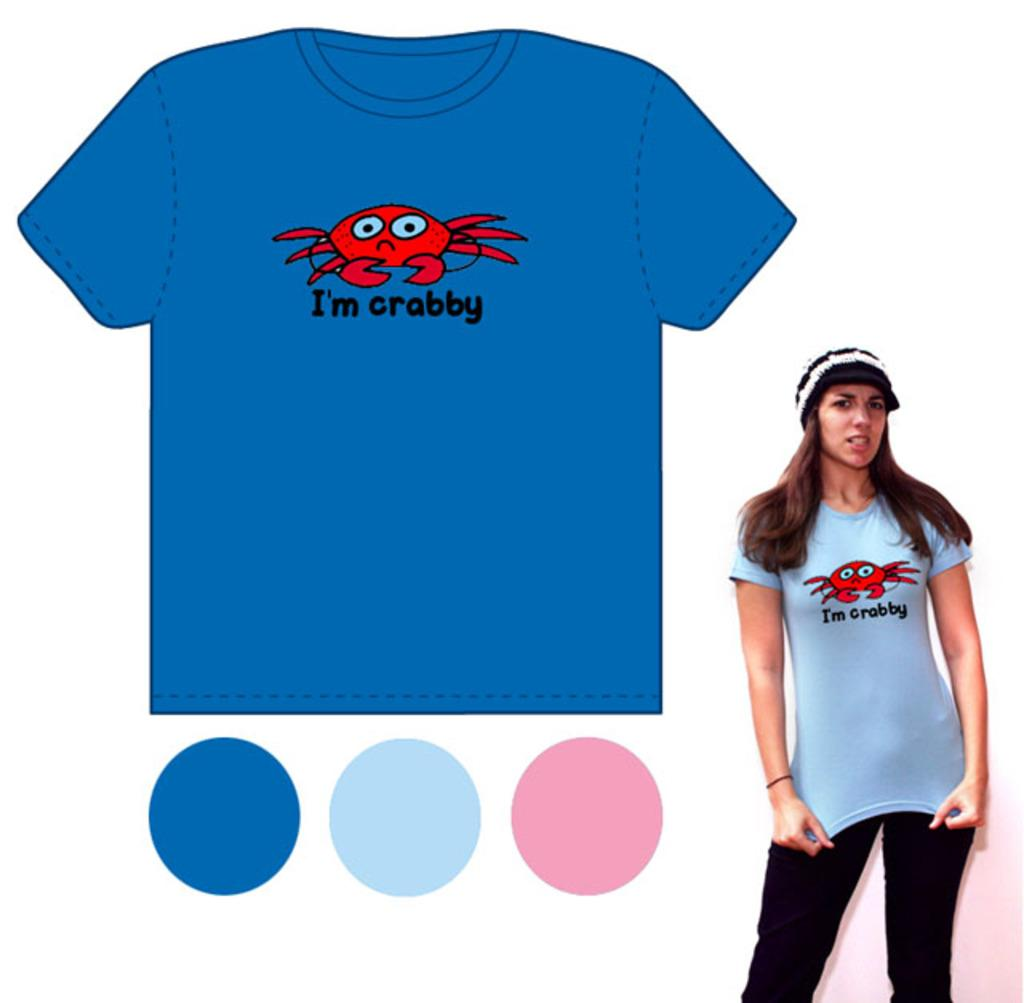Provide a one-sentence caption for the provided image. a blue shirt with a crab on it that says crabby. 